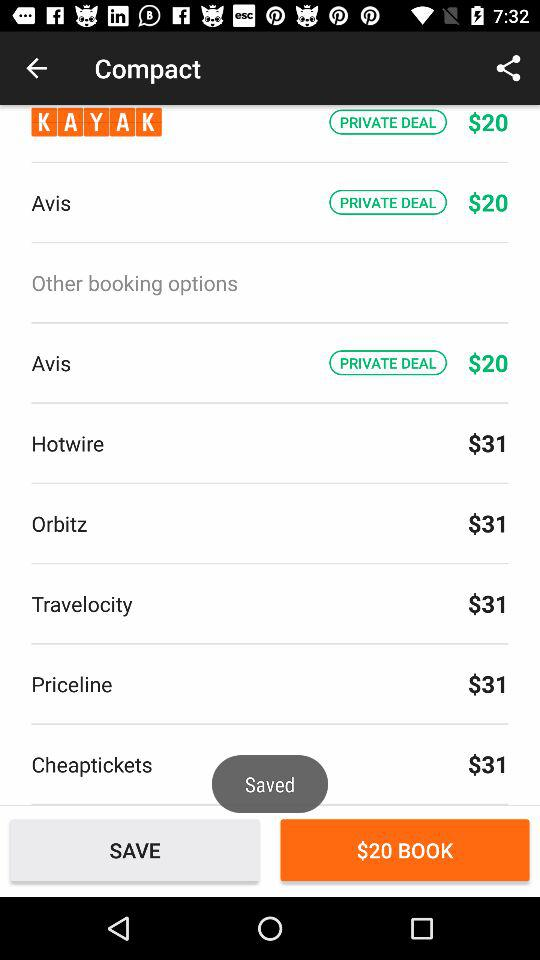How much do "Cheaptickets" cost?
Answer the question using a single word or phrase. "Cheaptickets" cost $31. 